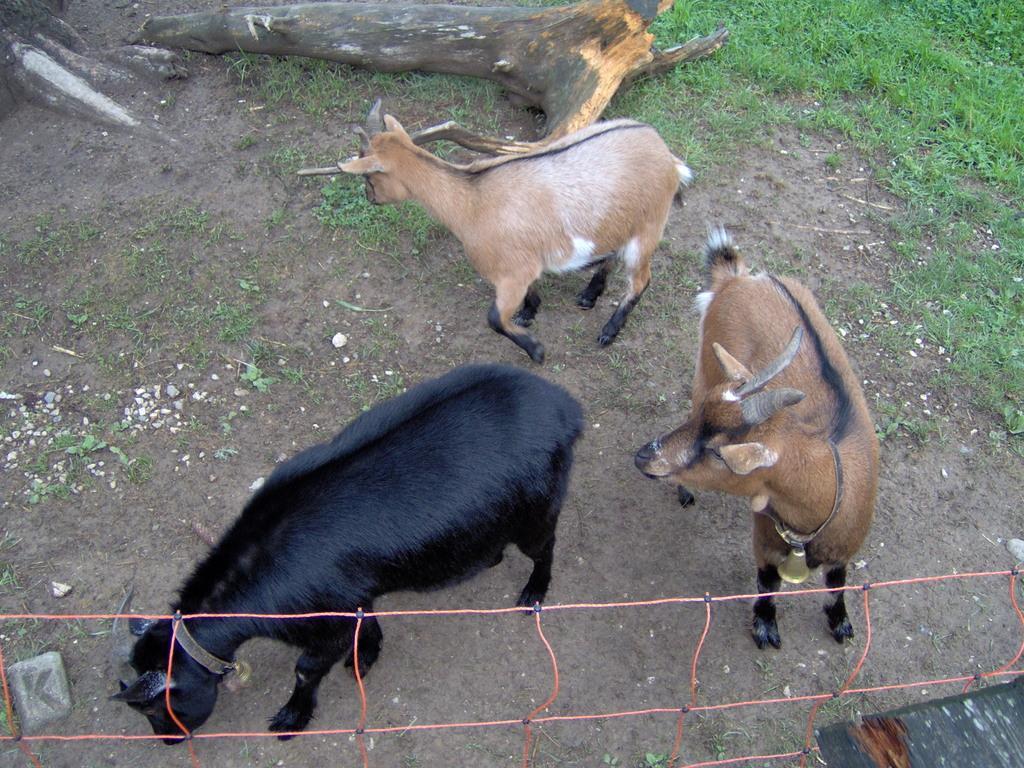Could you give a brief overview of what you see in this image? In this image there are three goats standing on the ground. There is a bell which is attached to the goat which is on the right side. In the background there is a tree trunk on the ground. On the right side top there is grass. At the bottom there is net. There are stones on the ground. 